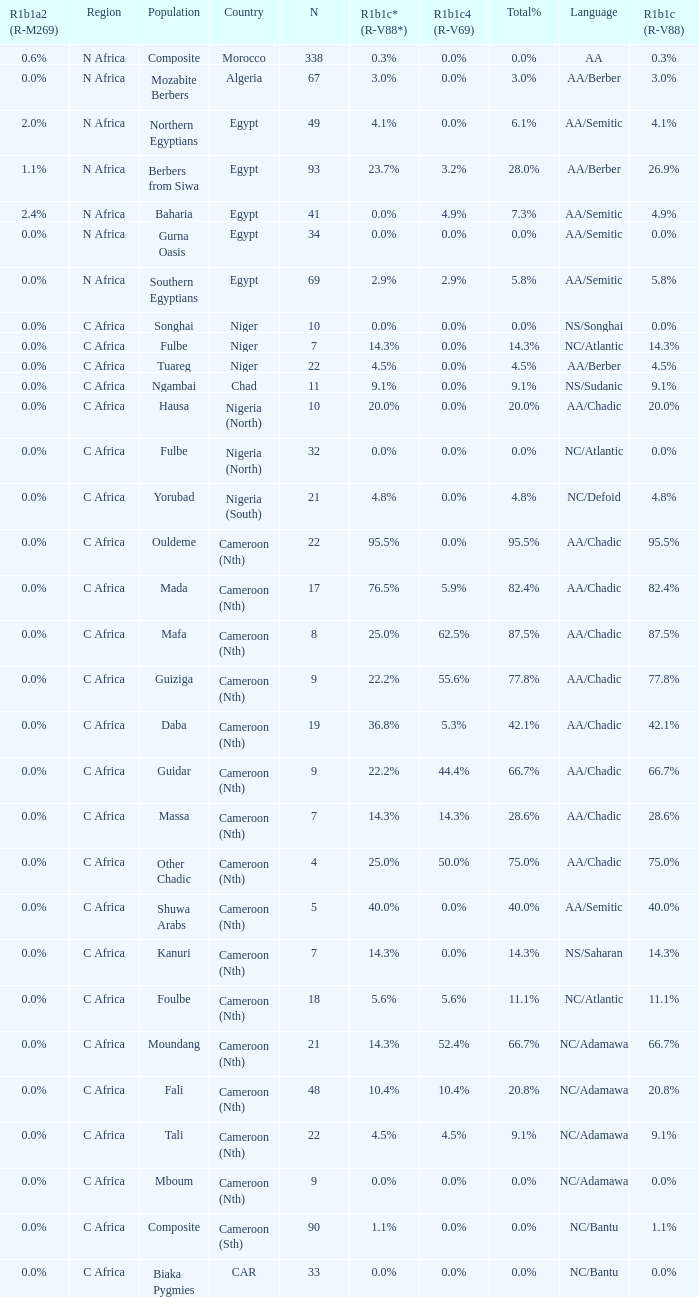5% cumulative percentage? 4.5%. 